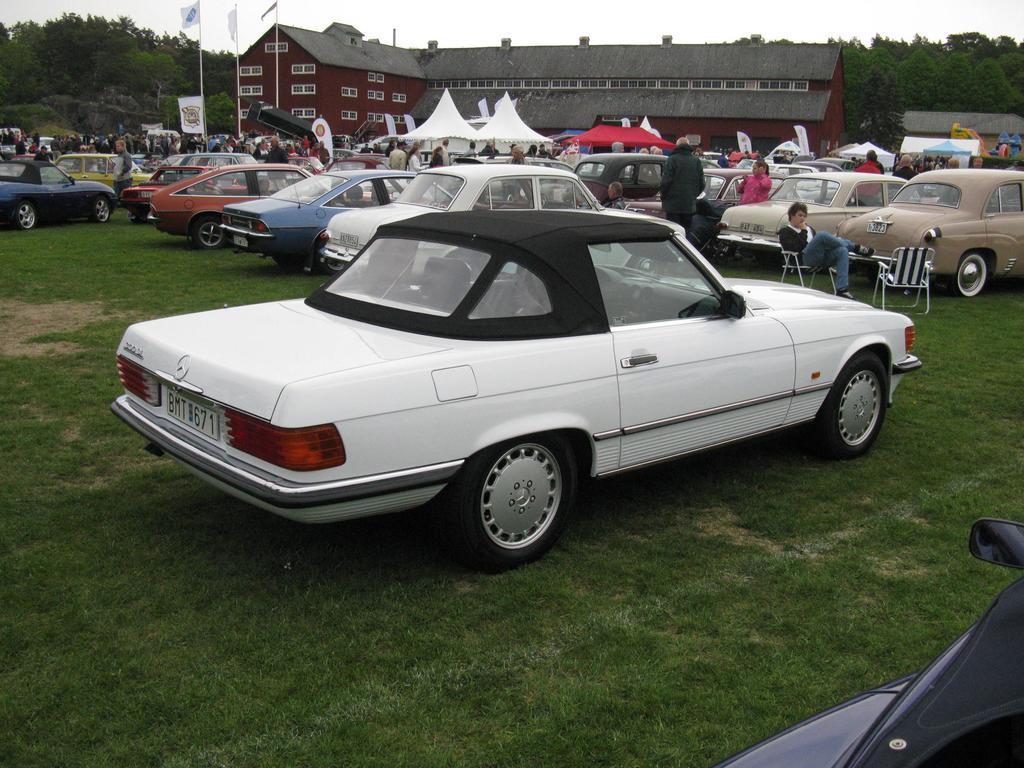Please provide a concise description of this image. In this image few vehicles are on the grassland. Left side a person is sitting on the chair. Before him there is a chair. Few persons are on the grassland. Middle of the image there are few tents. Behind there is a building. Left top there are few poles having flags. Background there are few trees. Top of the image there is sky. 